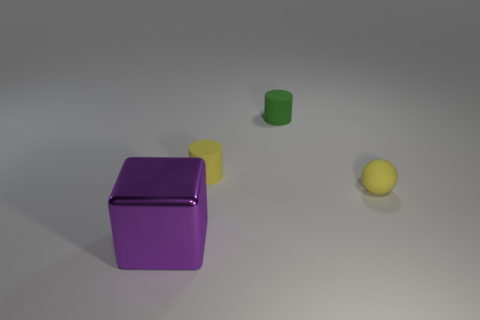The other object that is the same shape as the green rubber thing is what color?
Offer a very short reply. Yellow. The green object is what shape?
Your answer should be very brief. Cylinder. What number of things are either tiny green shiny blocks or yellow objects?
Your response must be concise. 2. Does the matte thing left of the green rubber cylinder have the same color as the tiny matte object that is on the right side of the small green cylinder?
Your answer should be compact. Yes. What number of other objects are the same shape as the tiny green thing?
Ensure brevity in your answer.  1. Are there any big purple metallic objects?
Provide a short and direct response. Yes. How many things are big purple shiny objects or yellow things that are to the left of the green matte thing?
Make the answer very short. 2. There is a yellow thing that is behind the yellow ball; does it have the same size as the tiny green matte cylinder?
Offer a very short reply. Yes. How many other things are the same size as the purple block?
Your response must be concise. 0. The small matte ball is what color?
Ensure brevity in your answer.  Yellow. 